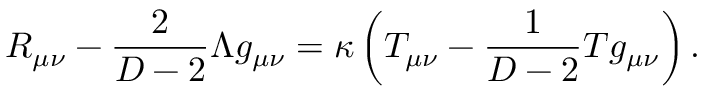<formula> <loc_0><loc_0><loc_500><loc_500>R _ { \mu \nu } - { \frac { 2 } { D - 2 } } \Lambda g _ { \mu \nu } = \kappa \left ( T _ { \mu \nu } - { \frac { 1 } { D - 2 } } T g _ { \mu \nu } \right ) .</formula> 